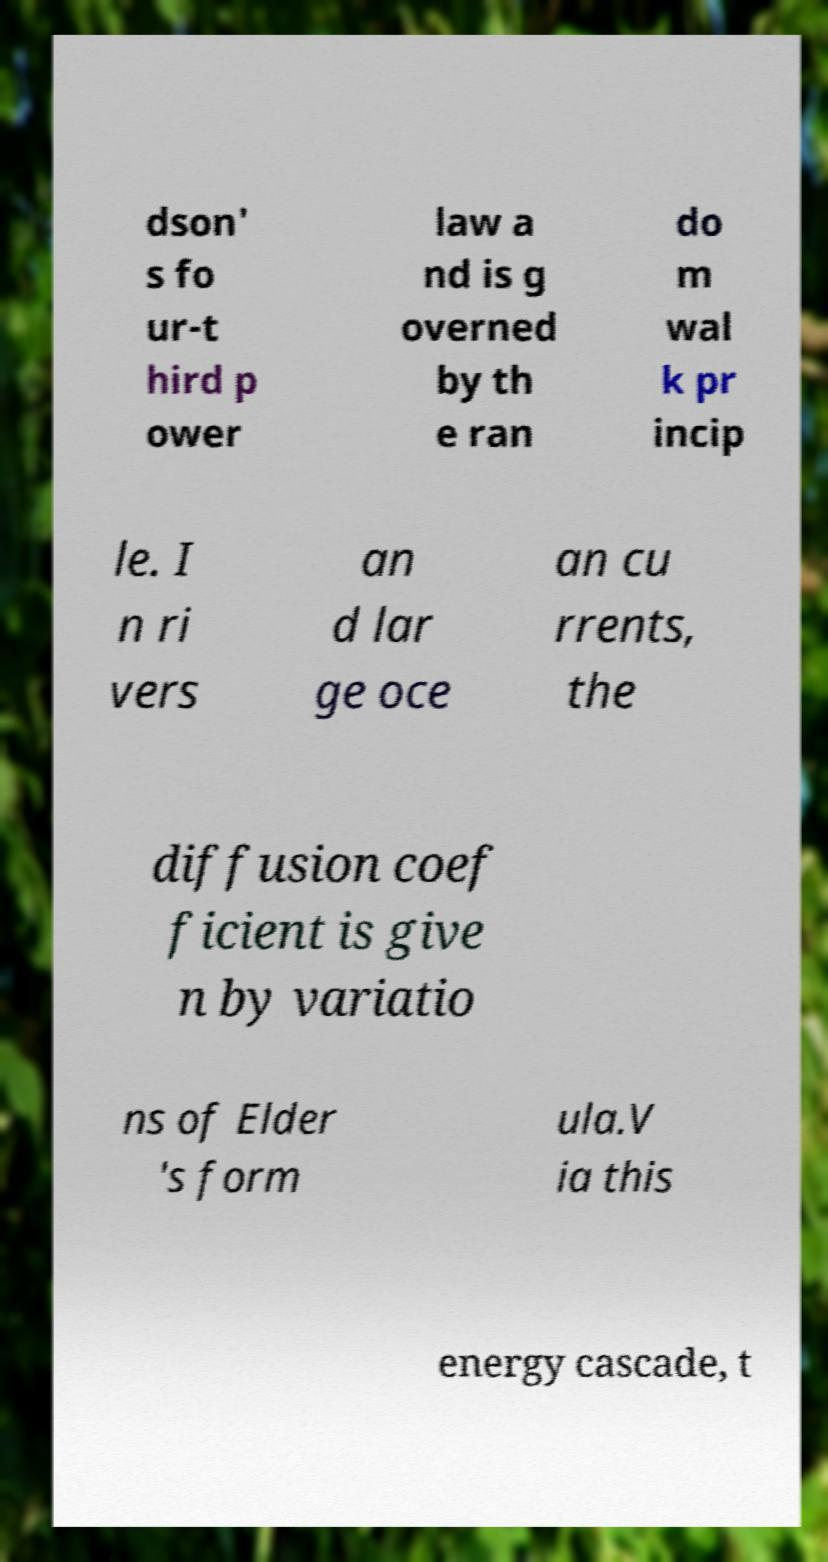I need the written content from this picture converted into text. Can you do that? dson' s fo ur-t hird p ower law a nd is g overned by th e ran do m wal k pr incip le. I n ri vers an d lar ge oce an cu rrents, the diffusion coef ficient is give n by variatio ns of Elder 's form ula.V ia this energy cascade, t 